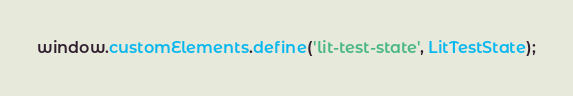Convert code to text. <code><loc_0><loc_0><loc_500><loc_500><_JavaScript_>window.customElements.define('lit-test-state', LitTestState);
</code> 